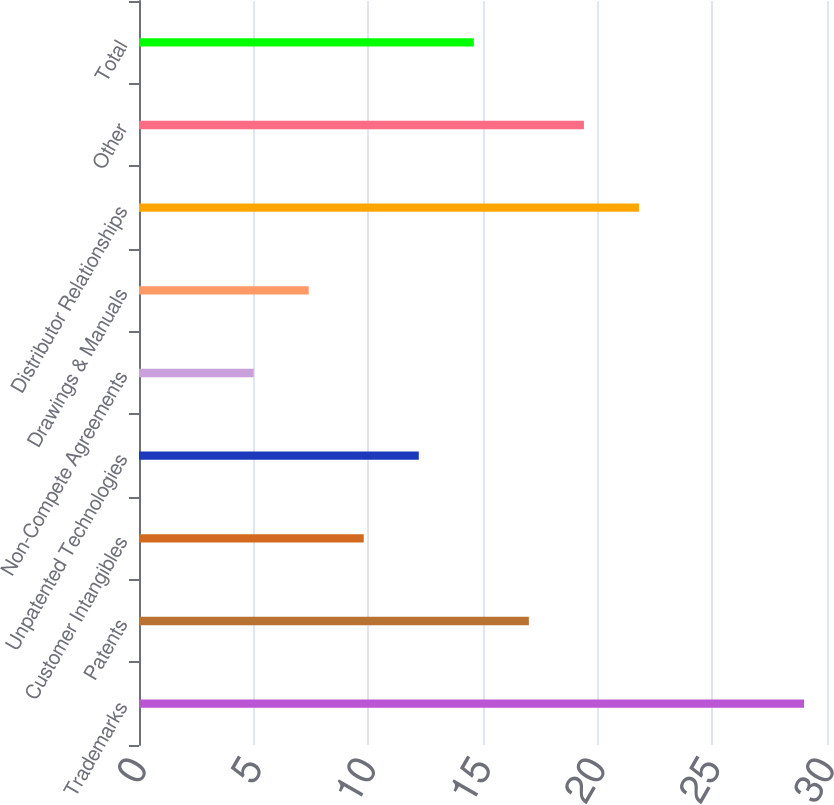<chart> <loc_0><loc_0><loc_500><loc_500><bar_chart><fcel>Trademarks<fcel>Patents<fcel>Customer Intangibles<fcel>Unpatented Technologies<fcel>Non-Compete Agreements<fcel>Drawings & Manuals<fcel>Distributor Relationships<fcel>Other<fcel>Total<nl><fcel>29<fcel>17<fcel>9.8<fcel>12.2<fcel>5<fcel>7.4<fcel>21.8<fcel>19.4<fcel>14.6<nl></chart> 